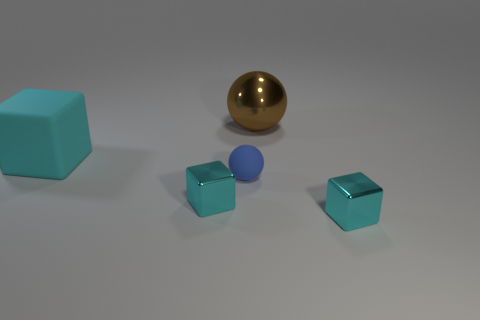There is a metal object that is to the right of the brown sphere; is its size the same as the cyan rubber block?
Your answer should be very brief. No. The cyan rubber object is what shape?
Provide a short and direct response. Cube. Is the large object behind the large matte cube made of the same material as the blue ball?
Your answer should be compact. No. Are there any small metallic things of the same color as the big metallic sphere?
Provide a short and direct response. No. Does the tiny thing to the right of the brown sphere have the same shape as the cyan thing that is behind the tiny blue rubber object?
Your answer should be compact. Yes. Is there a brown sphere that has the same material as the blue ball?
Your answer should be very brief. No. How many cyan things are small shiny things or big matte things?
Provide a succinct answer. 3. There is a thing that is both to the right of the large cube and behind the small blue object; how big is it?
Offer a very short reply. Large. Are there more small rubber spheres in front of the big metallic object than cyan rubber things?
Your response must be concise. No. What number of balls are brown metal things or cyan metal objects?
Your response must be concise. 1. 